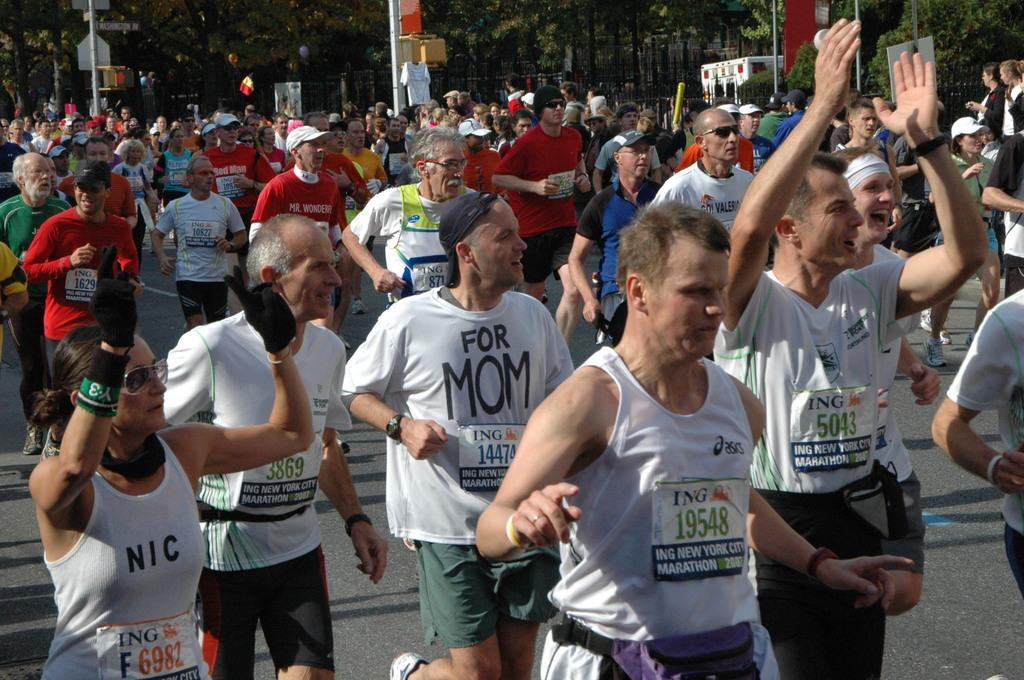What are the people in the image doing? The people in the image are running on the road. What can be seen beside the road in the image? Trees and poles are visible beside the road in the image. What type of leaf is being folded by the people in the image? There is no leaf present in the image, and the people are running, not folding anything. 